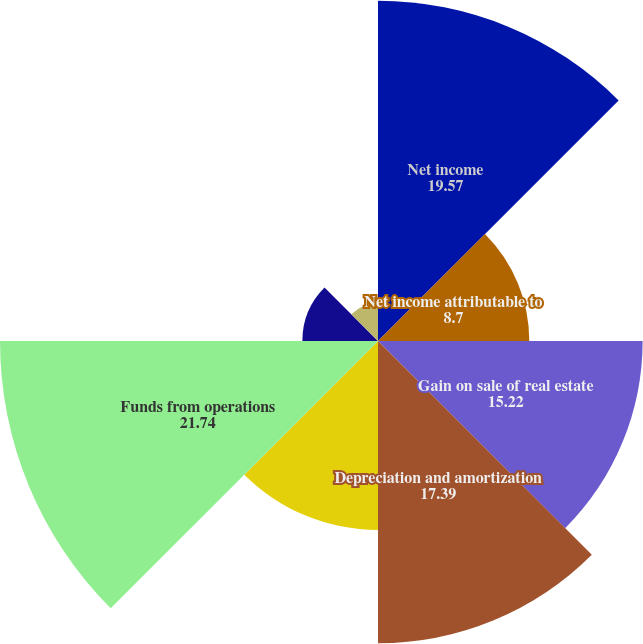Convert chart. <chart><loc_0><loc_0><loc_500><loc_500><pie_chart><fcel>Net income<fcel>Net income attributable to<fcel>Gain on sale of real estate<fcel>Depreciation and amortization<fcel>Amortization of initial direct<fcel>Funds from operations<fcel>Dividends on preferred shares<fcel>Income attributable to<nl><fcel>19.57%<fcel>8.7%<fcel>15.22%<fcel>17.39%<fcel>10.87%<fcel>21.74%<fcel>4.35%<fcel>2.17%<nl></chart> 